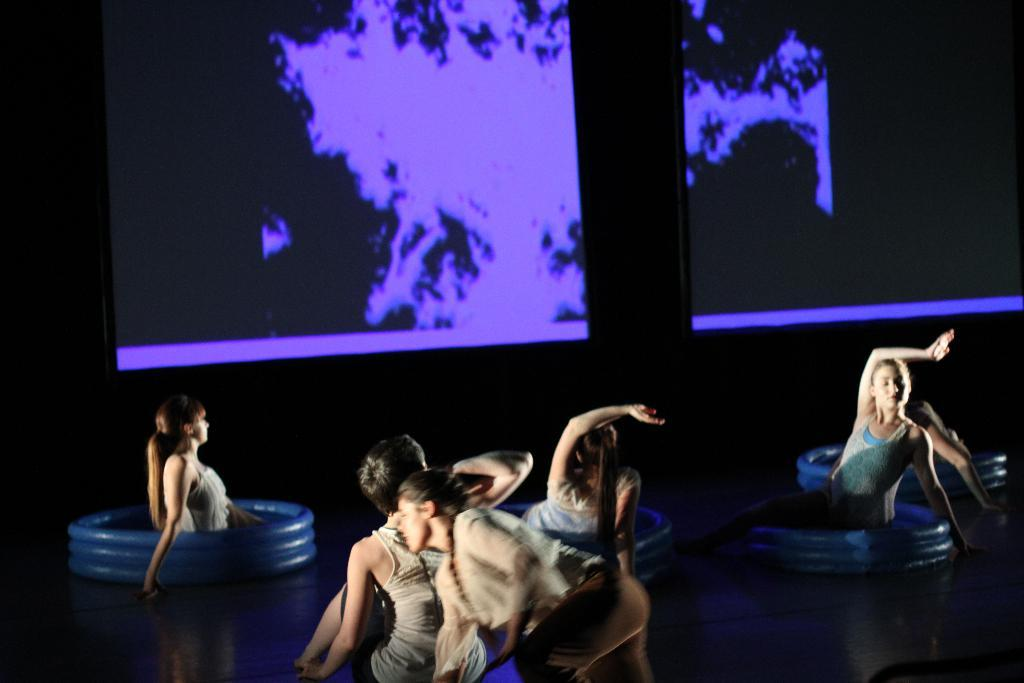What is happening in the image involving a group of people? There is a group of people dancing on a stage in the image. What can be seen on the stage besides the people? There are inflatable objects on the stage. What is present behind the people on the stage? There are screens behind the people on the stage. How would you describe the lighting in the image? The background of the image is dark. Can you see a rabbit hopping through the wilderness in the image? No, there is no rabbit or wilderness present in the image; it features a group of people dancing on a stage with inflatable objects and screens. 